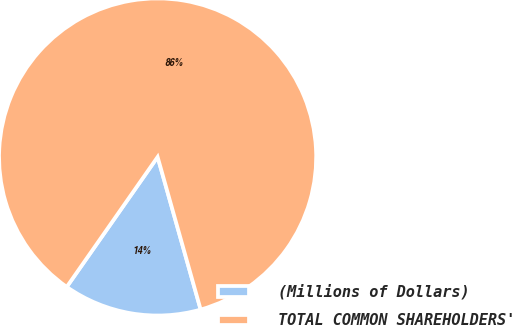<chart> <loc_0><loc_0><loc_500><loc_500><pie_chart><fcel>(Millions of Dollars)<fcel>TOTAL COMMON SHAREHOLDERS'<nl><fcel>14.09%<fcel>85.91%<nl></chart> 